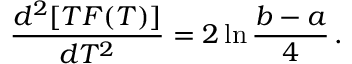Convert formula to latex. <formula><loc_0><loc_0><loc_500><loc_500>\frac { d ^ { 2 } [ T F ( T ) ] } { d T ^ { 2 } } = 2 \ln \frac { b - a } { 4 } \, .</formula> 